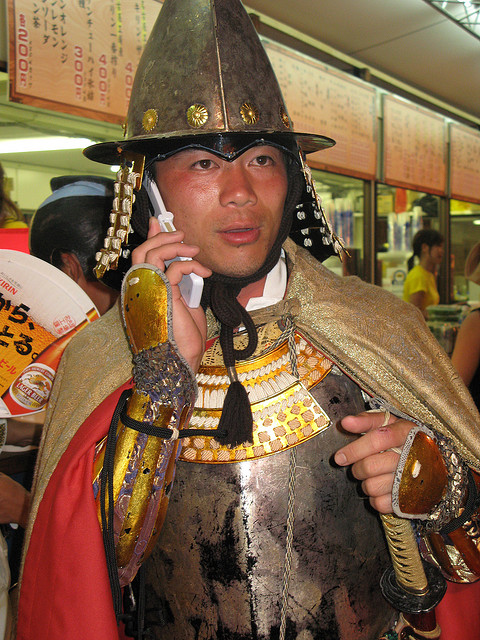Please extract the text content from this image. 200 300 400 3 RIN 